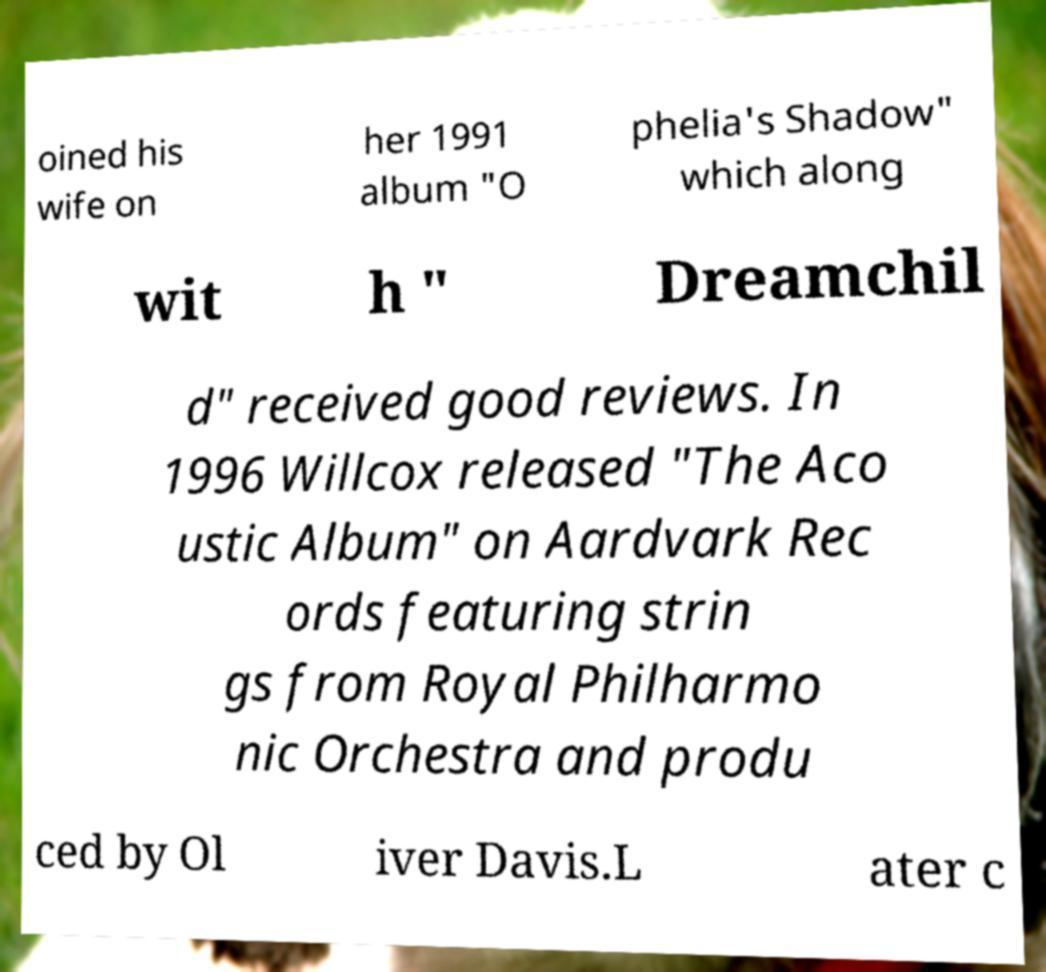Can you read and provide the text displayed in the image?This photo seems to have some interesting text. Can you extract and type it out for me? oined his wife on her 1991 album "O phelia's Shadow" which along wit h " Dreamchil d" received good reviews. In 1996 Willcox released "The Aco ustic Album" on Aardvark Rec ords featuring strin gs from Royal Philharmo nic Orchestra and produ ced by Ol iver Davis.L ater c 